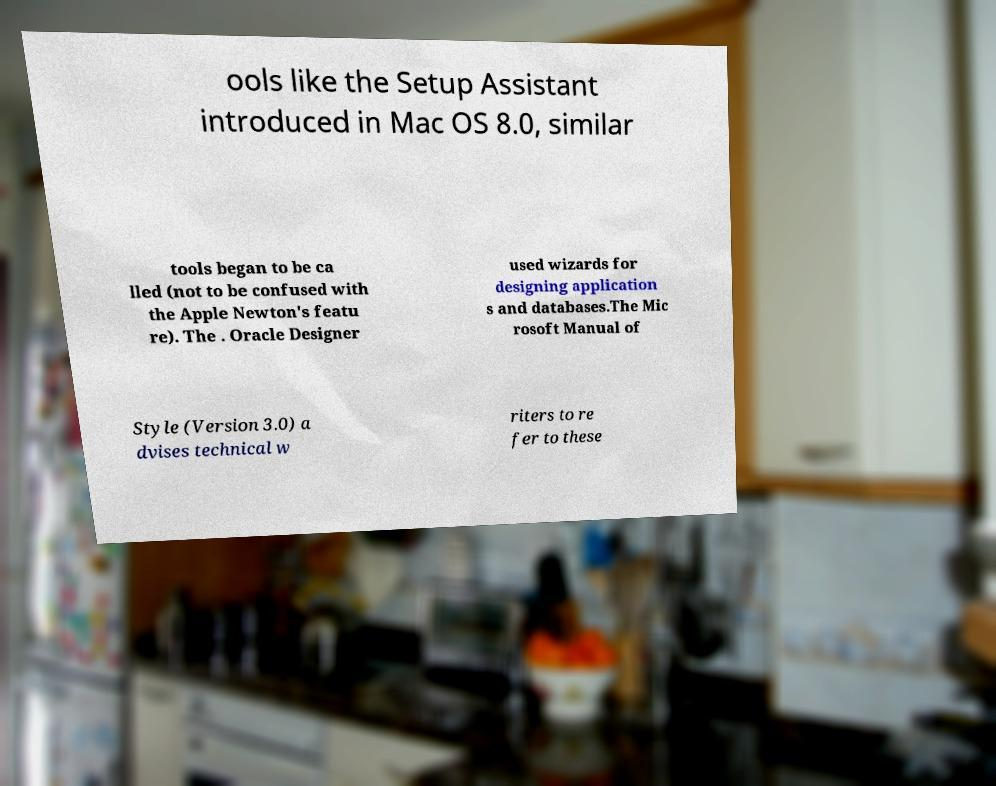I need the written content from this picture converted into text. Can you do that? ools like the Setup Assistant introduced in Mac OS 8.0, similar tools began to be ca lled (not to be confused with the Apple Newton's featu re). The . Oracle Designer used wizards for designing application s and databases.The Mic rosoft Manual of Style (Version 3.0) a dvises technical w riters to re fer to these 